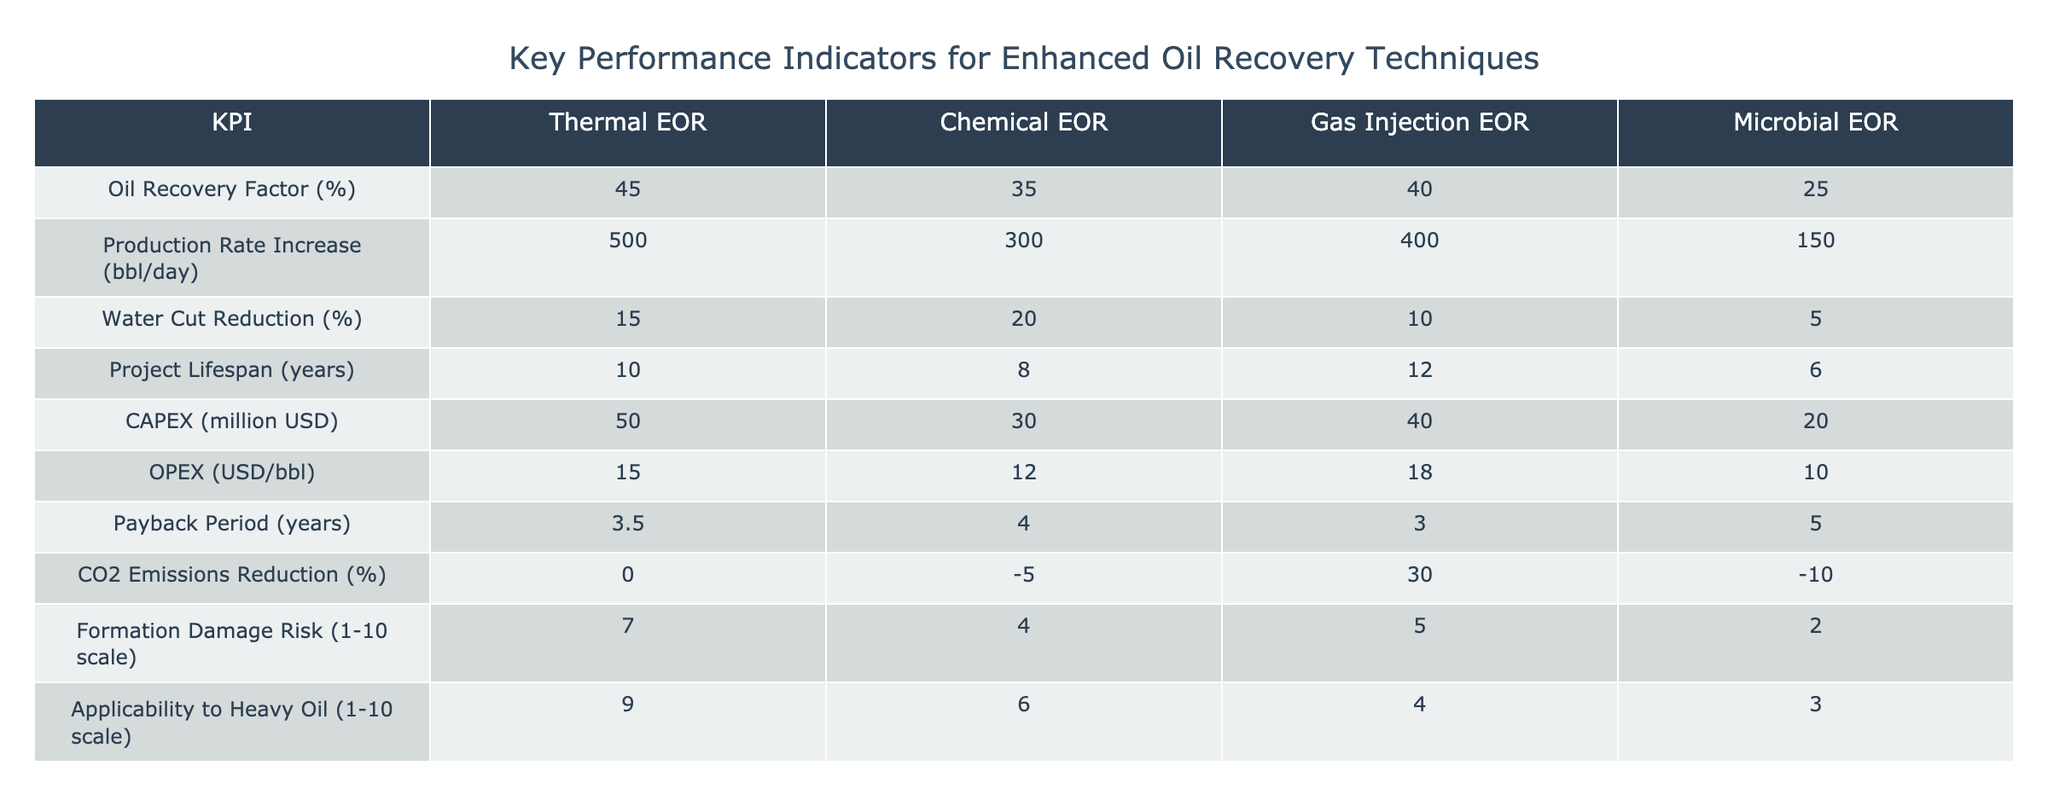What is the oil recovery factor for Gas Injection EOR? The table lists the oil recovery factor for Gas Injection EOR in the corresponding row under the "Oil Recovery Factor (%)" column. The value is 40%.
Answer: 40% Which enhanced oil recovery technique has the lowest production rate increase? By examining the "Production Rate Increase (bbl/day)" column, we see that Microbial EOR has the lowest value at 150 bbl/day.
Answer: 150 bbl/day What is the average payback period for Thermal and Gas Injection EOR techniques? The payback periods for Thermal EOR and Gas Injection EOR are 3.5 years and 3 years, respectively. To find the average, add these two values together (3.5 + 3) = 6.5 and divide by 2, resulting in an average of 3.25 years.
Answer: 3.25 years Is the CO2 emissions reduction for Chemical EOR positive? Looking at the "CO2 Emissions Reduction (%)" column, the value for Chemical EOR is -5%, which is not positive. Therefore, the answer is no.
Answer: No What is the difference in CAPEX between Chemical EOR and Microbial EOR? The CAPEX values for Chemical EOR and Microbial EOR are 30 million USD and 20 million USD, respectively. Subtracting these gives us 30 - 20 = 10 million USD.
Answer: 10 million USD Which EOR technique has the highest risk of formation damage? From the "Formation Damage Risk (1-10 scale)" column, we see Thermal EOR has the highest risk with a score of 7.
Answer: 7 What is the total oil recovery factor for Thermal EOR and Microbial EOR combined? The oil recovery factors for Thermal EOR and Microbial EOR are 45% and 25%, respectively. Adding these two values gives us 45 + 25 = 70%.
Answer: 70% Which EOR technique has the longest project lifespan and what is its duration? The "Project Lifespan (years)" column shows that Gas Injection EOR has the longest lifespan at 12 years.
Answer: 12 years Does Thermal EOR have a lower water cut reduction percentage compared to Gas Injection EOR? The table displays water cut reduction percentages of 15% for Thermal EOR and 10% for Gas Injection EOR. Since 15% is higher than 10%, the statement is false.
Answer: No 